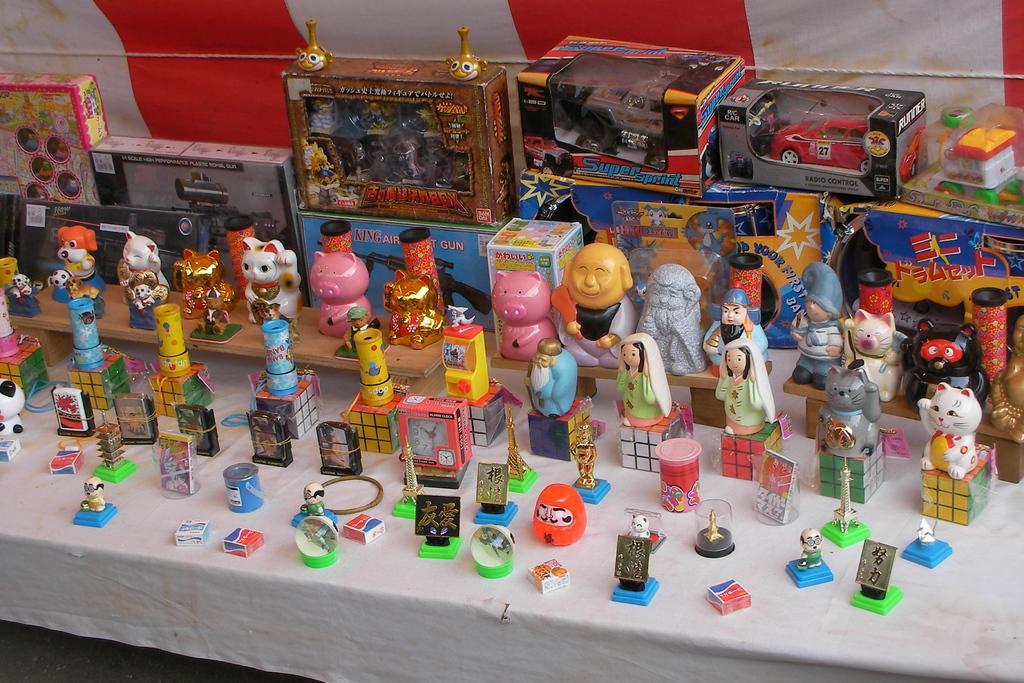How would you summarize this image in a sentence or two? In this picture I can see Rubik cubes, toys, an alarm clock, there are kind of boxes and there are some toys in the boxes, on the table, and in the background there is a rope and a cloth. 